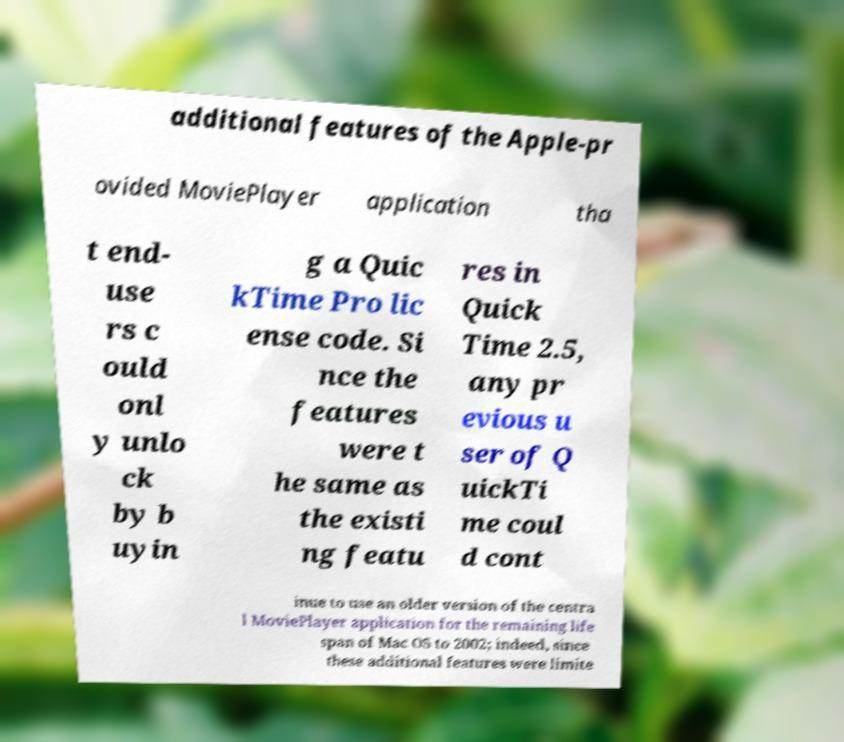There's text embedded in this image that I need extracted. Can you transcribe it verbatim? additional features of the Apple-pr ovided MoviePlayer application tha t end- use rs c ould onl y unlo ck by b uyin g a Quic kTime Pro lic ense code. Si nce the features were t he same as the existi ng featu res in Quick Time 2.5, any pr evious u ser of Q uickTi me coul d cont inue to use an older version of the centra l MoviePlayer application for the remaining life span of Mac OS to 2002; indeed, since these additional features were limite 